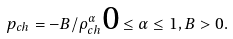<formula> <loc_0><loc_0><loc_500><loc_500>p _ { c h } = - B / { \rho } _ { c h } ^ { \alpha } \text  0\leq \alpha \leq 1, B>0.</formula> 